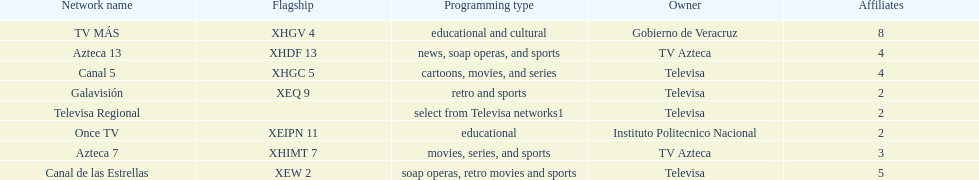Tell me the number of stations tv azteca owns. 2. Can you parse all the data within this table? {'header': ['Network name', 'Flagship', 'Programming type', 'Owner', 'Affiliates'], 'rows': [['TV MÁS', 'XHGV 4', 'educational and cultural', 'Gobierno de Veracruz', '8'], ['Azteca 13', 'XHDF 13', 'news, soap operas, and sports', 'TV Azteca', '4'], ['Canal 5', 'XHGC 5', 'cartoons, movies, and series', 'Televisa', '4'], ['Galavisión', 'XEQ 9', 'retro and sports', 'Televisa', '2'], ['Televisa Regional', '', 'select from Televisa networks1', 'Televisa', '2'], ['Once TV', 'XEIPN 11', 'educational', 'Instituto Politecnico Nacional', '2'], ['Azteca 7', 'XHIMT 7', 'movies, series, and sports', 'TV Azteca', '3'], ['Canal de las Estrellas', 'XEW 2', 'soap operas, retro movies and sports', 'Televisa', '5']]} 